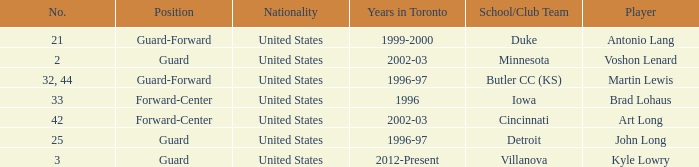How many schools did player number 3 play at? 1.0. Could you help me parse every detail presented in this table? {'header': ['No.', 'Position', 'Nationality', 'Years in Toronto', 'School/Club Team', 'Player'], 'rows': [['21', 'Guard-Forward', 'United States', '1999-2000', 'Duke', 'Antonio Lang'], ['2', 'Guard', 'United States', '2002-03', 'Minnesota', 'Voshon Lenard'], ['32, 44', 'Guard-Forward', 'United States', '1996-97', 'Butler CC (KS)', 'Martin Lewis'], ['33', 'Forward-Center', 'United States', '1996', 'Iowa', 'Brad Lohaus'], ['42', 'Forward-Center', 'United States', '2002-03', 'Cincinnati', 'Art Long'], ['25', 'Guard', 'United States', '1996-97', 'Detroit', 'John Long'], ['3', 'Guard', 'United States', '2012-Present', 'Villanova', 'Kyle Lowry']]} 